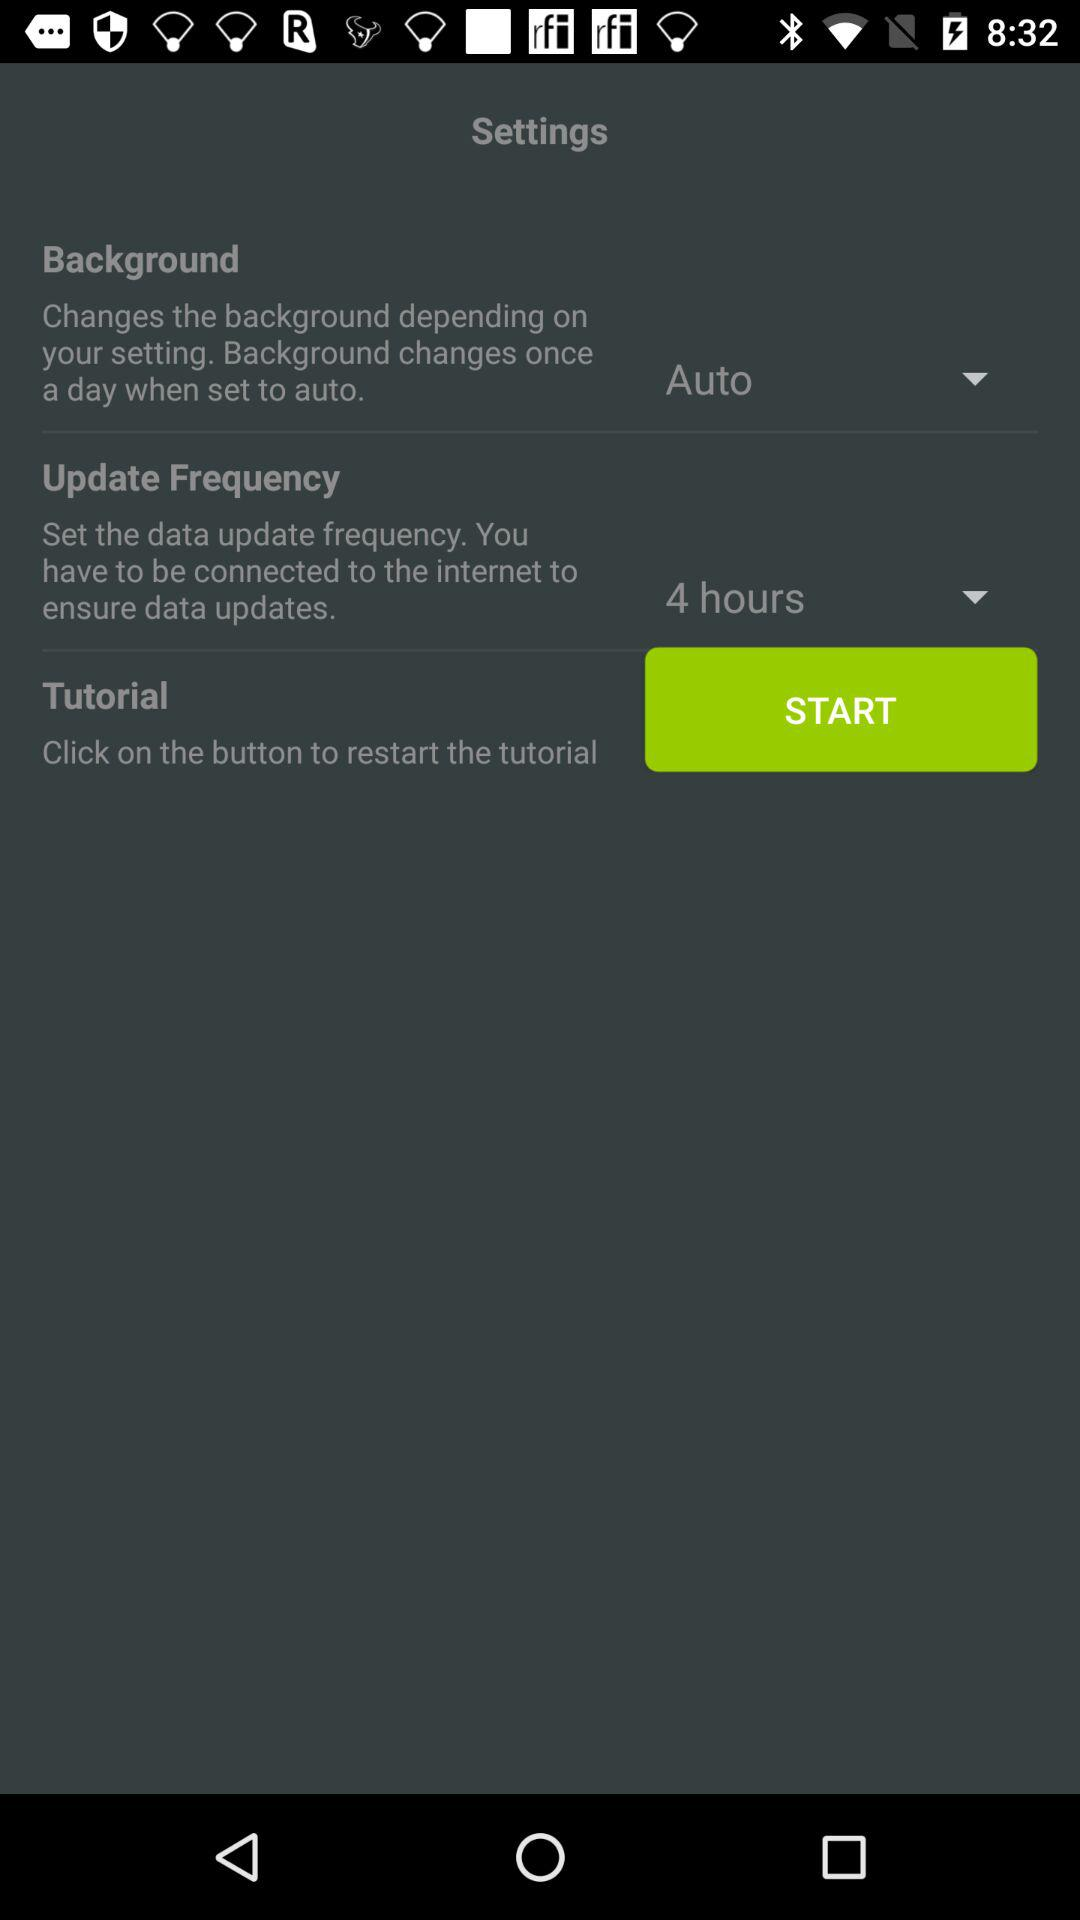What is the setting for the "Background"? The setting is "Auto". 